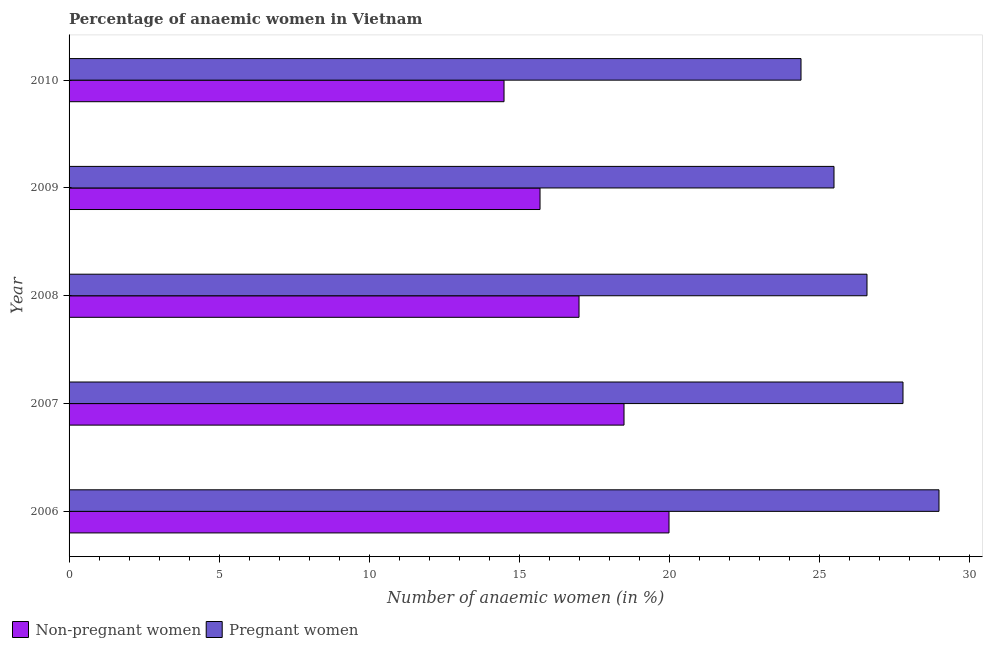How many different coloured bars are there?
Ensure brevity in your answer.  2. How many groups of bars are there?
Keep it short and to the point. 5. Are the number of bars on each tick of the Y-axis equal?
Ensure brevity in your answer.  Yes. How many bars are there on the 5th tick from the bottom?
Ensure brevity in your answer.  2. In how many cases, is the number of bars for a given year not equal to the number of legend labels?
Your response must be concise. 0. Across all years, what is the maximum percentage of pregnant anaemic women?
Provide a short and direct response. 29. Across all years, what is the minimum percentage of pregnant anaemic women?
Give a very brief answer. 24.4. In which year was the percentage of pregnant anaemic women minimum?
Ensure brevity in your answer.  2010. What is the total percentage of non-pregnant anaemic women in the graph?
Offer a terse response. 85.7. What is the difference between the percentage of non-pregnant anaemic women in 2009 and that in 2010?
Keep it short and to the point. 1.2. What is the difference between the percentage of non-pregnant anaemic women in 2010 and the percentage of pregnant anaemic women in 2007?
Provide a short and direct response. -13.3. What is the average percentage of non-pregnant anaemic women per year?
Provide a succinct answer. 17.14. In how many years, is the percentage of non-pregnant anaemic women greater than 27 %?
Ensure brevity in your answer.  0. What is the ratio of the percentage of pregnant anaemic women in 2007 to that in 2009?
Make the answer very short. 1.09. In how many years, is the percentage of non-pregnant anaemic women greater than the average percentage of non-pregnant anaemic women taken over all years?
Ensure brevity in your answer.  2. What does the 2nd bar from the top in 2010 represents?
Provide a short and direct response. Non-pregnant women. What does the 2nd bar from the bottom in 2010 represents?
Make the answer very short. Pregnant women. Are all the bars in the graph horizontal?
Make the answer very short. Yes. How many years are there in the graph?
Provide a short and direct response. 5. What is the difference between two consecutive major ticks on the X-axis?
Provide a succinct answer. 5. Does the graph contain any zero values?
Offer a very short reply. No. How many legend labels are there?
Offer a terse response. 2. How are the legend labels stacked?
Ensure brevity in your answer.  Horizontal. What is the title of the graph?
Ensure brevity in your answer.  Percentage of anaemic women in Vietnam. Does "Travel Items" appear as one of the legend labels in the graph?
Your answer should be compact. No. What is the label or title of the X-axis?
Make the answer very short. Number of anaemic women (in %). What is the Number of anaemic women (in %) in Non-pregnant women in 2006?
Make the answer very short. 20. What is the Number of anaemic women (in %) in Pregnant women in 2006?
Offer a terse response. 29. What is the Number of anaemic women (in %) in Non-pregnant women in 2007?
Provide a short and direct response. 18.5. What is the Number of anaemic women (in %) in Pregnant women in 2007?
Keep it short and to the point. 27.8. What is the Number of anaemic women (in %) in Non-pregnant women in 2008?
Make the answer very short. 17. What is the Number of anaemic women (in %) of Pregnant women in 2008?
Provide a short and direct response. 26.6. What is the Number of anaemic women (in %) in Non-pregnant women in 2009?
Keep it short and to the point. 15.7. What is the Number of anaemic women (in %) in Non-pregnant women in 2010?
Your answer should be compact. 14.5. What is the Number of anaemic women (in %) of Pregnant women in 2010?
Give a very brief answer. 24.4. Across all years, what is the minimum Number of anaemic women (in %) in Pregnant women?
Make the answer very short. 24.4. What is the total Number of anaemic women (in %) of Non-pregnant women in the graph?
Your answer should be very brief. 85.7. What is the total Number of anaemic women (in %) in Pregnant women in the graph?
Your response must be concise. 133.3. What is the difference between the Number of anaemic women (in %) of Non-pregnant women in 2006 and that in 2008?
Offer a very short reply. 3. What is the difference between the Number of anaemic women (in %) in Pregnant women in 2006 and that in 2009?
Your answer should be compact. 3.5. What is the difference between the Number of anaemic women (in %) of Pregnant women in 2007 and that in 2008?
Make the answer very short. 1.2. What is the difference between the Number of anaemic women (in %) in Non-pregnant women in 2007 and that in 2010?
Your answer should be very brief. 4. What is the difference between the Number of anaemic women (in %) in Pregnant women in 2007 and that in 2010?
Your answer should be very brief. 3.4. What is the difference between the Number of anaemic women (in %) in Non-pregnant women in 2008 and that in 2009?
Offer a very short reply. 1.3. What is the difference between the Number of anaemic women (in %) of Non-pregnant women in 2008 and that in 2010?
Give a very brief answer. 2.5. What is the difference between the Number of anaemic women (in %) of Non-pregnant women in 2006 and the Number of anaemic women (in %) of Pregnant women in 2008?
Offer a very short reply. -6.6. What is the difference between the Number of anaemic women (in %) of Non-pregnant women in 2006 and the Number of anaemic women (in %) of Pregnant women in 2010?
Keep it short and to the point. -4.4. What is the difference between the Number of anaemic women (in %) in Non-pregnant women in 2008 and the Number of anaemic women (in %) in Pregnant women in 2009?
Keep it short and to the point. -8.5. What is the average Number of anaemic women (in %) in Non-pregnant women per year?
Ensure brevity in your answer.  17.14. What is the average Number of anaemic women (in %) of Pregnant women per year?
Your response must be concise. 26.66. In the year 2007, what is the difference between the Number of anaemic women (in %) in Non-pregnant women and Number of anaemic women (in %) in Pregnant women?
Offer a terse response. -9.3. In the year 2009, what is the difference between the Number of anaemic women (in %) in Non-pregnant women and Number of anaemic women (in %) in Pregnant women?
Ensure brevity in your answer.  -9.8. In the year 2010, what is the difference between the Number of anaemic women (in %) of Non-pregnant women and Number of anaemic women (in %) of Pregnant women?
Ensure brevity in your answer.  -9.9. What is the ratio of the Number of anaemic women (in %) in Non-pregnant women in 2006 to that in 2007?
Provide a short and direct response. 1.08. What is the ratio of the Number of anaemic women (in %) in Pregnant women in 2006 to that in 2007?
Offer a terse response. 1.04. What is the ratio of the Number of anaemic women (in %) in Non-pregnant women in 2006 to that in 2008?
Provide a short and direct response. 1.18. What is the ratio of the Number of anaemic women (in %) in Pregnant women in 2006 to that in 2008?
Offer a terse response. 1.09. What is the ratio of the Number of anaemic women (in %) in Non-pregnant women in 2006 to that in 2009?
Your response must be concise. 1.27. What is the ratio of the Number of anaemic women (in %) in Pregnant women in 2006 to that in 2009?
Make the answer very short. 1.14. What is the ratio of the Number of anaemic women (in %) in Non-pregnant women in 2006 to that in 2010?
Your response must be concise. 1.38. What is the ratio of the Number of anaemic women (in %) of Pregnant women in 2006 to that in 2010?
Give a very brief answer. 1.19. What is the ratio of the Number of anaemic women (in %) of Non-pregnant women in 2007 to that in 2008?
Offer a terse response. 1.09. What is the ratio of the Number of anaemic women (in %) in Pregnant women in 2007 to that in 2008?
Your answer should be very brief. 1.05. What is the ratio of the Number of anaemic women (in %) in Non-pregnant women in 2007 to that in 2009?
Make the answer very short. 1.18. What is the ratio of the Number of anaemic women (in %) of Pregnant women in 2007 to that in 2009?
Your answer should be very brief. 1.09. What is the ratio of the Number of anaemic women (in %) in Non-pregnant women in 2007 to that in 2010?
Provide a short and direct response. 1.28. What is the ratio of the Number of anaemic women (in %) in Pregnant women in 2007 to that in 2010?
Give a very brief answer. 1.14. What is the ratio of the Number of anaemic women (in %) of Non-pregnant women in 2008 to that in 2009?
Provide a succinct answer. 1.08. What is the ratio of the Number of anaemic women (in %) in Pregnant women in 2008 to that in 2009?
Provide a succinct answer. 1.04. What is the ratio of the Number of anaemic women (in %) of Non-pregnant women in 2008 to that in 2010?
Give a very brief answer. 1.17. What is the ratio of the Number of anaemic women (in %) in Pregnant women in 2008 to that in 2010?
Keep it short and to the point. 1.09. What is the ratio of the Number of anaemic women (in %) in Non-pregnant women in 2009 to that in 2010?
Give a very brief answer. 1.08. What is the ratio of the Number of anaemic women (in %) in Pregnant women in 2009 to that in 2010?
Your answer should be very brief. 1.05. What is the difference between the highest and the lowest Number of anaemic women (in %) in Pregnant women?
Your answer should be compact. 4.6. 